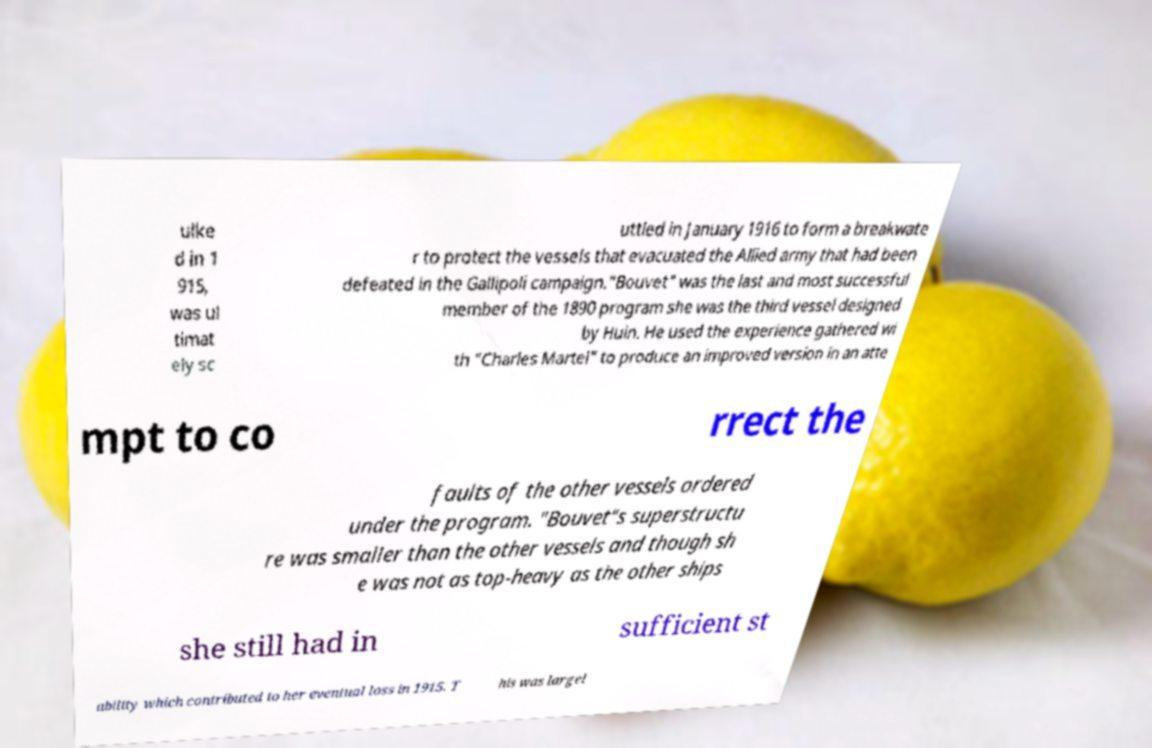Could you assist in decoding the text presented in this image and type it out clearly? ulke d in 1 915, was ul timat ely sc uttled in January 1916 to form a breakwate r to protect the vessels that evacuated the Allied army that had been defeated in the Gallipoli campaign."Bouvet" was the last and most successful member of the 1890 program she was the third vessel designed by Huin. He used the experience gathered wi th "Charles Martel" to produce an improved version in an atte mpt to co rrect the faults of the other vessels ordered under the program. "Bouvet"s superstructu re was smaller than the other vessels and though sh e was not as top-heavy as the other ships she still had in sufficient st ability which contributed to her eventual loss in 1915. T his was largel 